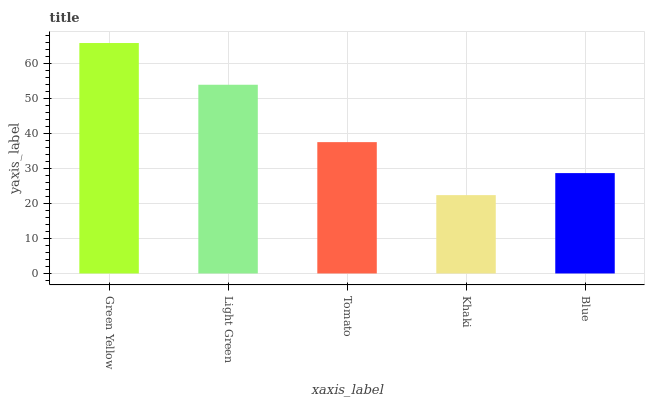Is Khaki the minimum?
Answer yes or no. Yes. Is Green Yellow the maximum?
Answer yes or no. Yes. Is Light Green the minimum?
Answer yes or no. No. Is Light Green the maximum?
Answer yes or no. No. Is Green Yellow greater than Light Green?
Answer yes or no. Yes. Is Light Green less than Green Yellow?
Answer yes or no. Yes. Is Light Green greater than Green Yellow?
Answer yes or no. No. Is Green Yellow less than Light Green?
Answer yes or no. No. Is Tomato the high median?
Answer yes or no. Yes. Is Tomato the low median?
Answer yes or no. Yes. Is Green Yellow the high median?
Answer yes or no. No. Is Blue the low median?
Answer yes or no. No. 